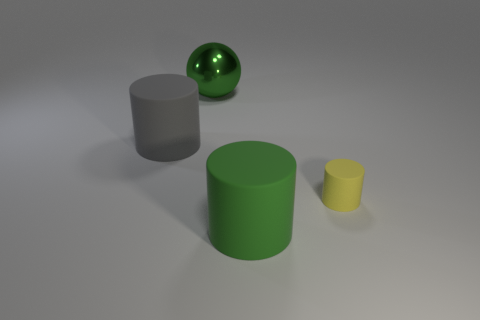Add 4 gray things. How many objects exist? 8 Subtract all balls. How many objects are left? 3 Subtract all purple rubber cylinders. Subtract all big metal balls. How many objects are left? 3 Add 1 yellow objects. How many yellow objects are left? 2 Add 2 small blocks. How many small blocks exist? 2 Subtract 0 brown cubes. How many objects are left? 4 